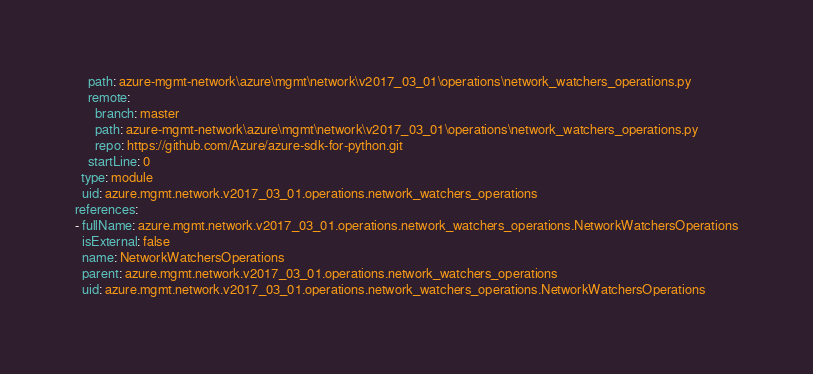<code> <loc_0><loc_0><loc_500><loc_500><_YAML_>    path: azure-mgmt-network\azure\mgmt\network\v2017_03_01\operations\network_watchers_operations.py
    remote:
      branch: master
      path: azure-mgmt-network\azure\mgmt\network\v2017_03_01\operations\network_watchers_operations.py
      repo: https://github.com/Azure/azure-sdk-for-python.git
    startLine: 0
  type: module
  uid: azure.mgmt.network.v2017_03_01.operations.network_watchers_operations
references:
- fullName: azure.mgmt.network.v2017_03_01.operations.network_watchers_operations.NetworkWatchersOperations
  isExternal: false
  name: NetworkWatchersOperations
  parent: azure.mgmt.network.v2017_03_01.operations.network_watchers_operations
  uid: azure.mgmt.network.v2017_03_01.operations.network_watchers_operations.NetworkWatchersOperations
</code> 